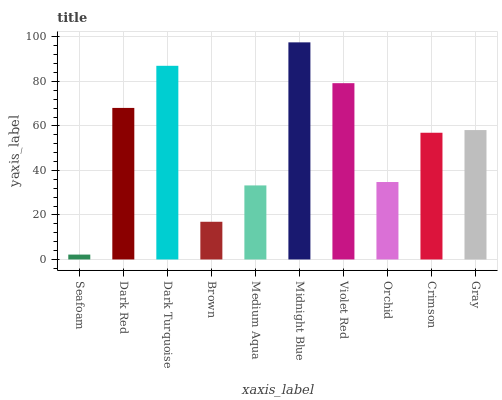Is Seafoam the minimum?
Answer yes or no. Yes. Is Midnight Blue the maximum?
Answer yes or no. Yes. Is Dark Red the minimum?
Answer yes or no. No. Is Dark Red the maximum?
Answer yes or no. No. Is Dark Red greater than Seafoam?
Answer yes or no. Yes. Is Seafoam less than Dark Red?
Answer yes or no. Yes. Is Seafoam greater than Dark Red?
Answer yes or no. No. Is Dark Red less than Seafoam?
Answer yes or no. No. Is Gray the high median?
Answer yes or no. Yes. Is Crimson the low median?
Answer yes or no. Yes. Is Medium Aqua the high median?
Answer yes or no. No. Is Dark Red the low median?
Answer yes or no. No. 